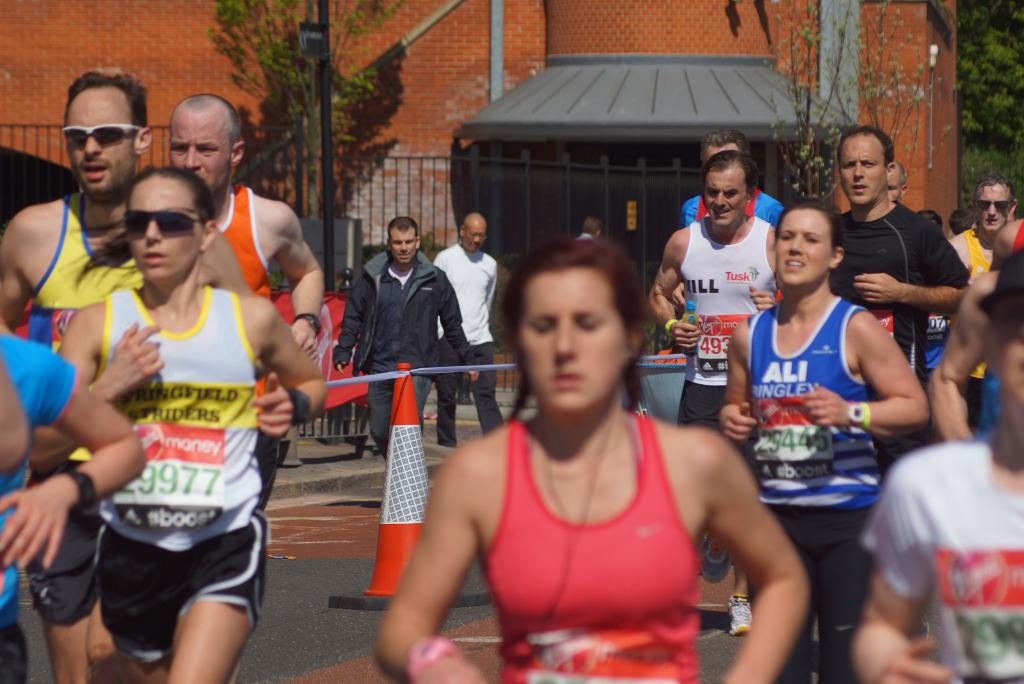What kinds of organizations might be sponsoring this race, considering the visible logos and race bibs? The race features sponsorship from diverse organizations, including charities like 'Tusk' and 'ALI,' and corporate sponsors such as 'Boost'. These bodies likely support the event to promote community engagement, increase their visibility, and contribute to charitable causes. 